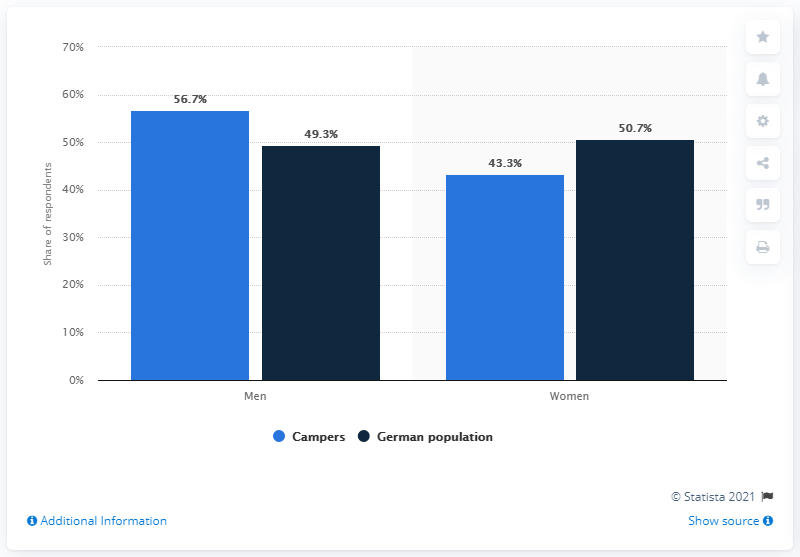Point out several critical features in this image. In the German population aged 14 and older, 49.3% were men. 